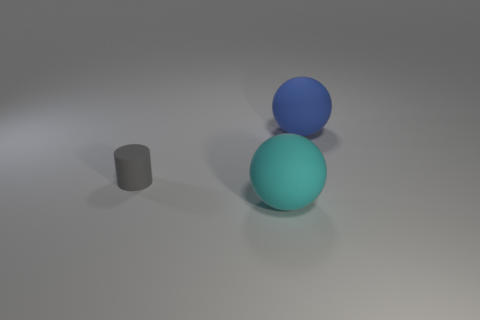Is the number of large cyan balls that are in front of the blue matte thing the same as the number of small gray things?
Your answer should be compact. Yes. Are the sphere that is in front of the tiny matte cylinder and the sphere that is behind the gray rubber thing made of the same material?
Offer a terse response. Yes. What is the shape of the large matte thing that is left of the matte object that is on the right side of the cyan matte sphere?
Provide a succinct answer. Sphere. There is a small cylinder that is the same material as the big cyan ball; what is its color?
Provide a short and direct response. Gray. There is another object that is the same size as the cyan matte thing; what shape is it?
Your answer should be very brief. Sphere. The blue rubber object is what size?
Provide a short and direct response. Large. Do the rubber object that is behind the small object and the ball that is in front of the gray matte cylinder have the same size?
Your answer should be compact. Yes. What color is the thing left of the big rubber ball that is in front of the large blue matte sphere?
Give a very brief answer. Gray. There is a blue object that is the same size as the cyan matte ball; what material is it?
Offer a very short reply. Rubber. How many matte objects are large green spheres or blue objects?
Offer a very short reply. 1. 